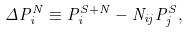<formula> <loc_0><loc_0><loc_500><loc_500>\Delta P ^ { N } _ { i } \equiv P ^ { S + N } _ { i } - N _ { i j } P ^ { S } _ { j } ,</formula> 